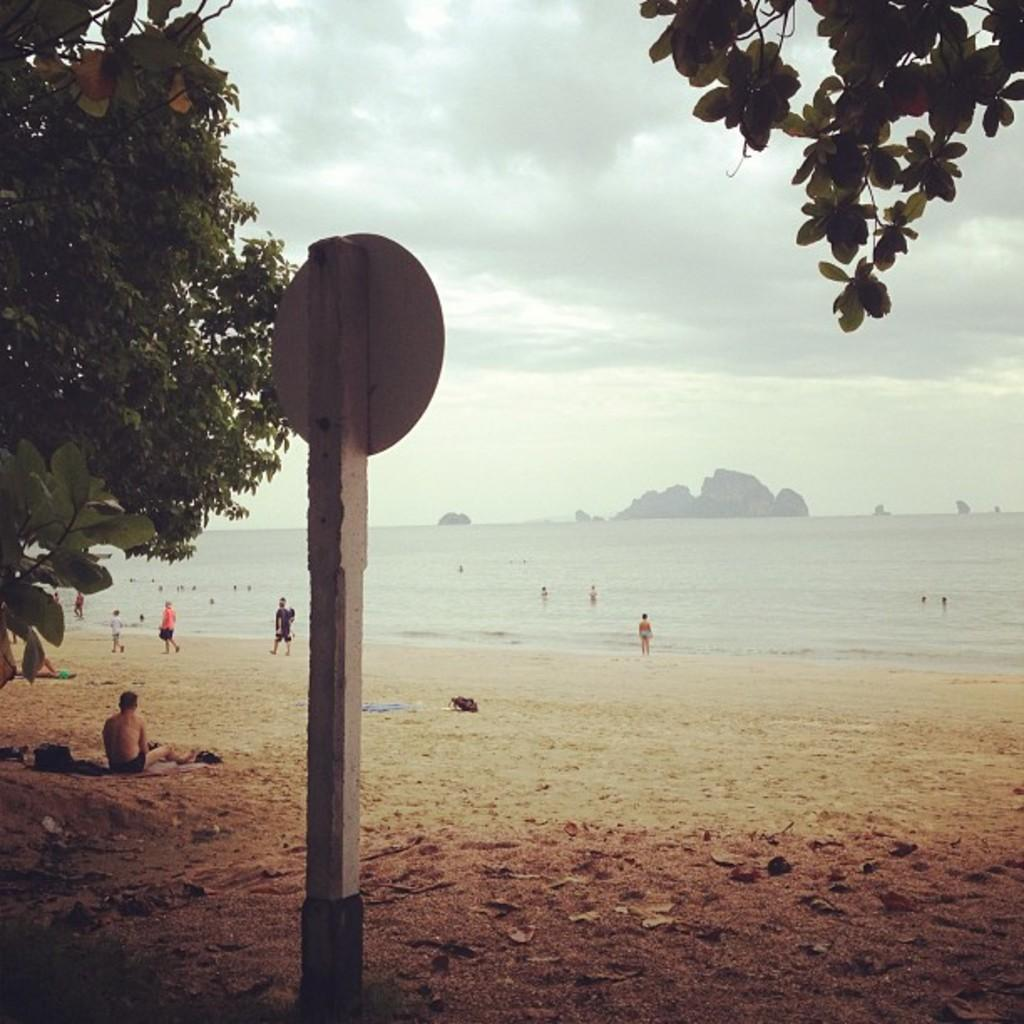What is the main object in the foreground of the image? There is a pole in the image. What is located near the pole? There is a board in the image. What type of vegetation can be seen in the image? There are leaves visible in the image. What can be seen in the background of the image? There are people and water visible in the background, and the sky appears to be cloudy. What type of landscape is depicted in the image? The image seems to depict hills. What type of substance is being used to create the coastline in the image? There is no coastline present in the image; it depicts hills and a pole with a board. How many flowers can be seen growing near the pole in the image? There are no flowers visible in the image; it only features leaves, a pole, and a board. 